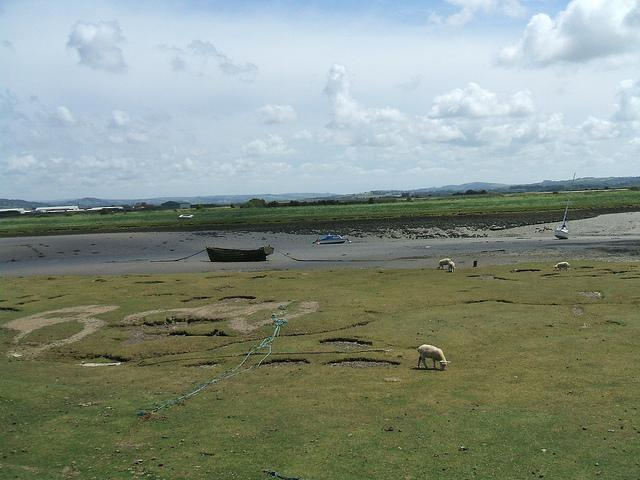What has dried up and stopped the boats from moving? Please explain your reasoning. water. Water has dried. 